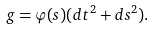Convert formula to latex. <formula><loc_0><loc_0><loc_500><loc_500>g = \varphi ( s ) ( d t ^ { 2 } + d s ^ { 2 } ) .</formula> 